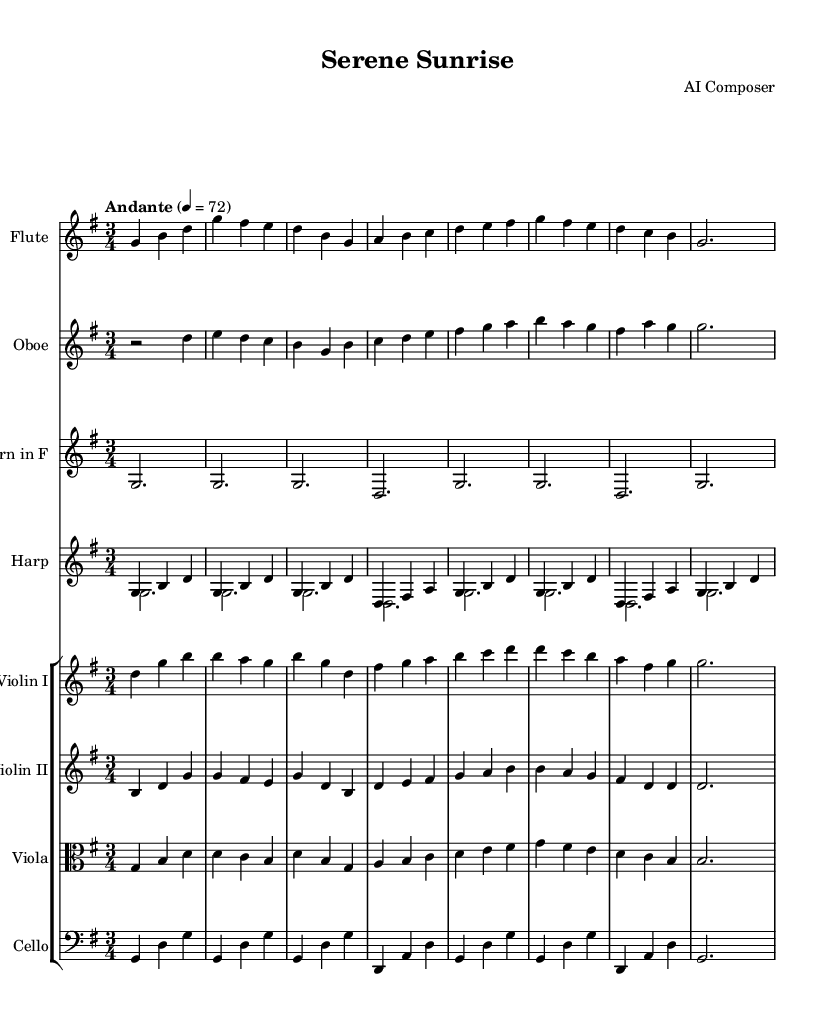What is the title of this piece? The title is located at the top of the sheet music, clearly labeled.
Answer: Serene Sunrise What is the key signature of this music? The key signature is indicated by the number of sharps or flats on the staff. This piece has one sharp, which corresponds to the G major scale.
Answer: G major What is the time signature of this music? The time signature is represented by two numbers at the beginning of the score, indicating the number of beats per measure and the note value of each beat. Here, it shows three beats per measure.
Answer: 3/4 What is the tempo marking of the piece? The tempo marking is typically found at the beginning of the score and indicates the speed of the piece. In this case, it specifies "Andante," suggesting a moderately slow pace.
Answer: Andante Which instrument has a dynamic marking in this composition? Dynamic markings indicate the volume or tone of a passage. In this score, the flute part includes "dynamicUp," which indicates that it should be played with a rising dynamic.
Answer: Flute How many instruments are featured in this composition? The number of staves in the score indicates the different instruments used. This score has eight staves, each representing a different instrument or part.
Answer: Eight Which instruments are in the string section of this piece? The string section can be identified by the instrument names listed in the associated staves. In this score, the violin I, violin II, viola, and cello comprise the string section.
Answer: Violin I, Violin II, Viola, Cello 